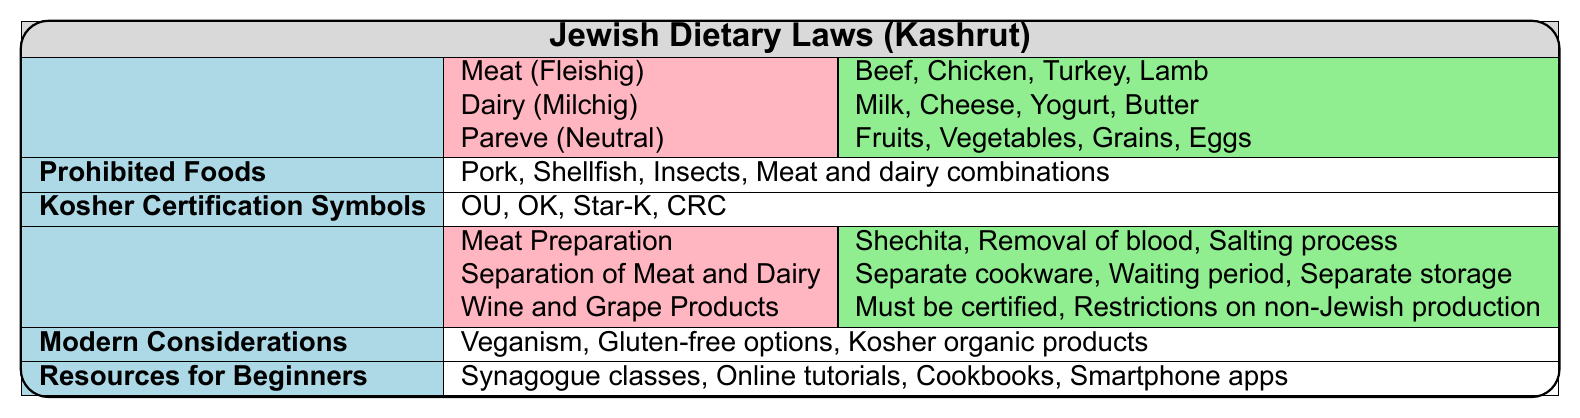What are the three main kosher food categories? The table explicitly lists the three main kosher food categories as: Meat (Fleishig), Dairy (Milchig), and Pareve (Neutral).
Answer: Meat, Dairy, Pareve Which category includes fruits and vegetables? The table indicates that fruits and vegetables fall under the Pareve (Neutral) category, which is designated for neutral foods.
Answer: Pareve (Neutral) Are insects considered kosher? The table explicitly states that insects are prohibited foods, which means they are not considered kosher.
Answer: No How many types of meat are listed under the Meat (Fleishig) category? The table shows four specific types of meat listed under the Meat (Fleishig) category: Beef, Chicken, Turkey, and Lamb. Therefore, there are 4 types.
Answer: 4 types Which kosher certification symbols are mentioned? The table lists four kosher certification symbols: OU (Orthodox Union), OK (Organized Kashrut Laboratories), Star-K, and CRC (Chicago Rabbinical Council).
Answer: OU, OK, Star-K, CRC What is one dietary rule regarding meat and dairy? The table indicates that one important rule is the separation of meat and dairy, with specific practices related to cookware and storage.
Answer: Separation of meat and dairy Is kosher certification required for wine? The table specifies that wine and grape products must be certified kosher, indicating that certification is necessary.
Answer: Yes How many dietary rules are outlined in the table? From the table, three distinct dietary rules are provided: Meat Preparation, Separation of Meat and Dairy, and Wine and Grape Products. So, there are 3 rules.
Answer: 3 dietary rules What is a modern consideration mentioned in the table? The table highlights that modern considerations include veganism, gluten-free options, kosher organic products, and plant-based meat alternatives, so one example is veganism.
Answer: Veganism If you are learning about kosher cooking, which resources can you utilize? The table suggests multiple resources such as local synagogue classes, online cooking tutorials, kosher cookbooks, and smartphone apps for product verification, offering a range of options for beginners.
Answer: Local classes, online tutorials, cookbooks, apps What is the significance of the waiting period between consuming meat and dairy? The table notes that one of the dietary rules is a waiting period between consuming meat and dairy, which is important for maintaining kosher practices as it separates the two categories.
Answer: Important for kosher practices 